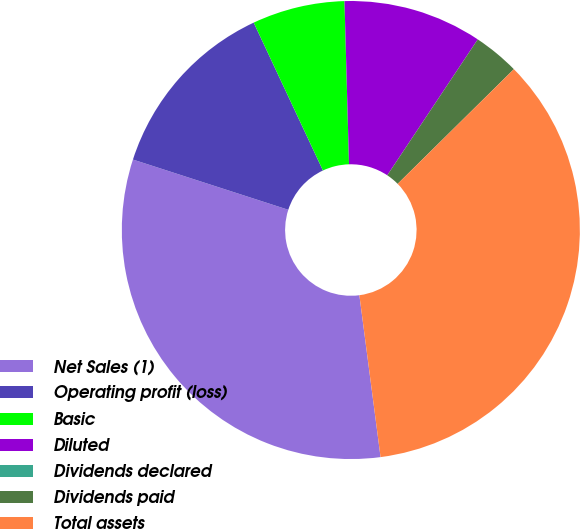Convert chart. <chart><loc_0><loc_0><loc_500><loc_500><pie_chart><fcel>Net Sales (1)<fcel>Operating profit (loss)<fcel>Basic<fcel>Diluted<fcel>Dividends declared<fcel>Dividends paid<fcel>Total assets<nl><fcel>32.05%<fcel>13.05%<fcel>6.53%<fcel>9.79%<fcel>0.0%<fcel>3.26%<fcel>35.32%<nl></chart> 